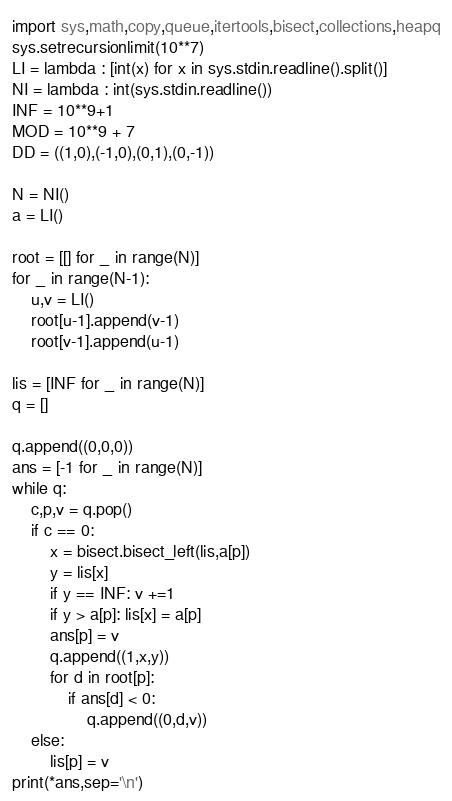<code> <loc_0><loc_0><loc_500><loc_500><_Python_>import sys,math,copy,queue,itertools,bisect,collections,heapq
sys.setrecursionlimit(10**7)
LI = lambda : [int(x) for x in sys.stdin.readline().split()]
NI = lambda : int(sys.stdin.readline())
INF = 10**9+1
MOD = 10**9 + 7
DD = ((1,0),(-1,0),(0,1),(0,-1))

N = NI()
a = LI()

root = [[] for _ in range(N)]
for _ in range(N-1):
    u,v = LI()
    root[u-1].append(v-1)
    root[v-1].append(u-1)

lis = [INF for _ in range(N)]
q = []

q.append((0,0,0))
ans = [-1 for _ in range(N)]
while q:
    c,p,v = q.pop()
    if c == 0:
        x = bisect.bisect_left(lis,a[p])
        y = lis[x]
        if y == INF: v +=1
        if y > a[p]: lis[x] = a[p]
        ans[p] = v
        q.append((1,x,y))
        for d in root[p]:
            if ans[d] < 0:
                q.append((0,d,v))
    else:
        lis[p] = v
print(*ans,sep='\n')</code> 